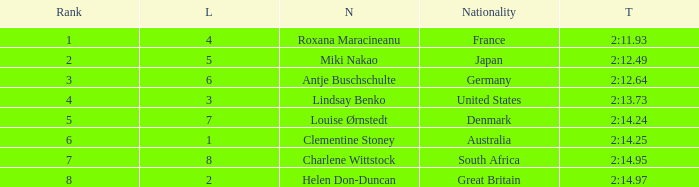What shows for nationality when there is a rank larger than 6, and a Time of 2:14.95? South Africa. 